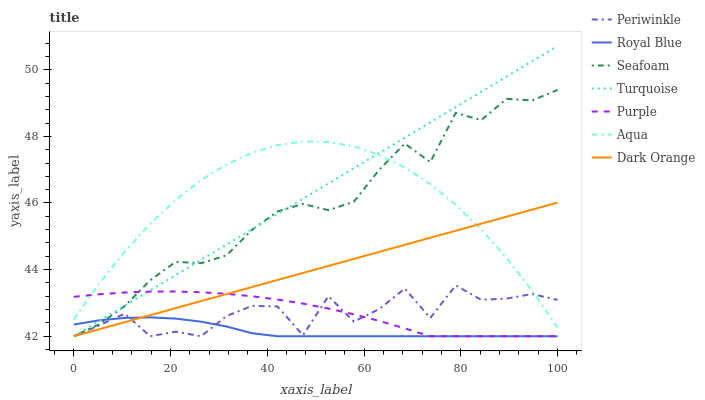Does Royal Blue have the minimum area under the curve?
Answer yes or no. Yes. Does Turquoise have the maximum area under the curve?
Answer yes or no. Yes. Does Purple have the minimum area under the curve?
Answer yes or no. No. Does Purple have the maximum area under the curve?
Answer yes or no. No. Is Dark Orange the smoothest?
Answer yes or no. Yes. Is Periwinkle the roughest?
Answer yes or no. Yes. Is Turquoise the smoothest?
Answer yes or no. No. Is Turquoise the roughest?
Answer yes or no. No. Does Dark Orange have the lowest value?
Answer yes or no. Yes. Does Aqua have the lowest value?
Answer yes or no. No. Does Turquoise have the highest value?
Answer yes or no. Yes. Does Purple have the highest value?
Answer yes or no. No. Is Royal Blue less than Aqua?
Answer yes or no. Yes. Is Aqua greater than Royal Blue?
Answer yes or no. Yes. Does Turquoise intersect Purple?
Answer yes or no. Yes. Is Turquoise less than Purple?
Answer yes or no. No. Is Turquoise greater than Purple?
Answer yes or no. No. Does Royal Blue intersect Aqua?
Answer yes or no. No. 